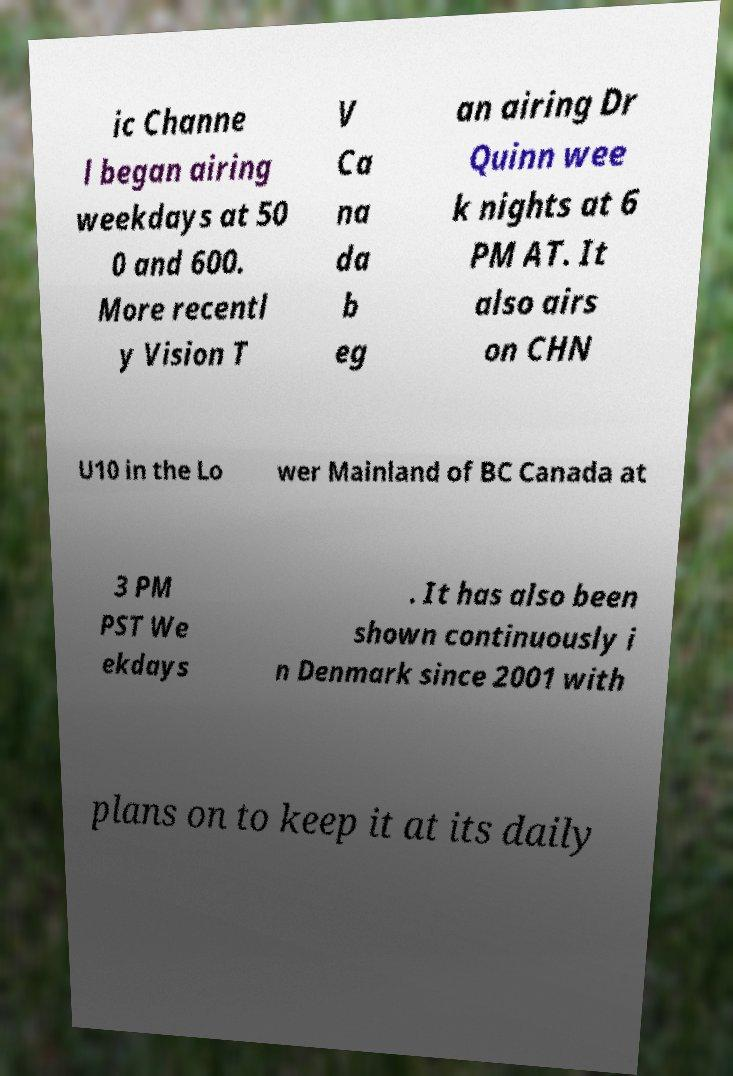What messages or text are displayed in this image? I need them in a readable, typed format. ic Channe l began airing weekdays at 50 0 and 600. More recentl y Vision T V Ca na da b eg an airing Dr Quinn wee k nights at 6 PM AT. It also airs on CHN U10 in the Lo wer Mainland of BC Canada at 3 PM PST We ekdays . It has also been shown continuously i n Denmark since 2001 with plans on to keep it at its daily 